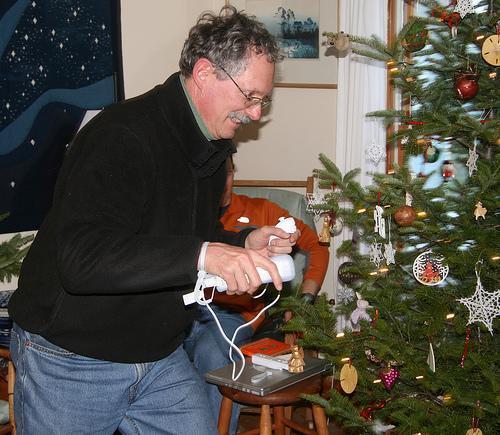How many people are there in this picture?
Give a very brief answer. 2. 